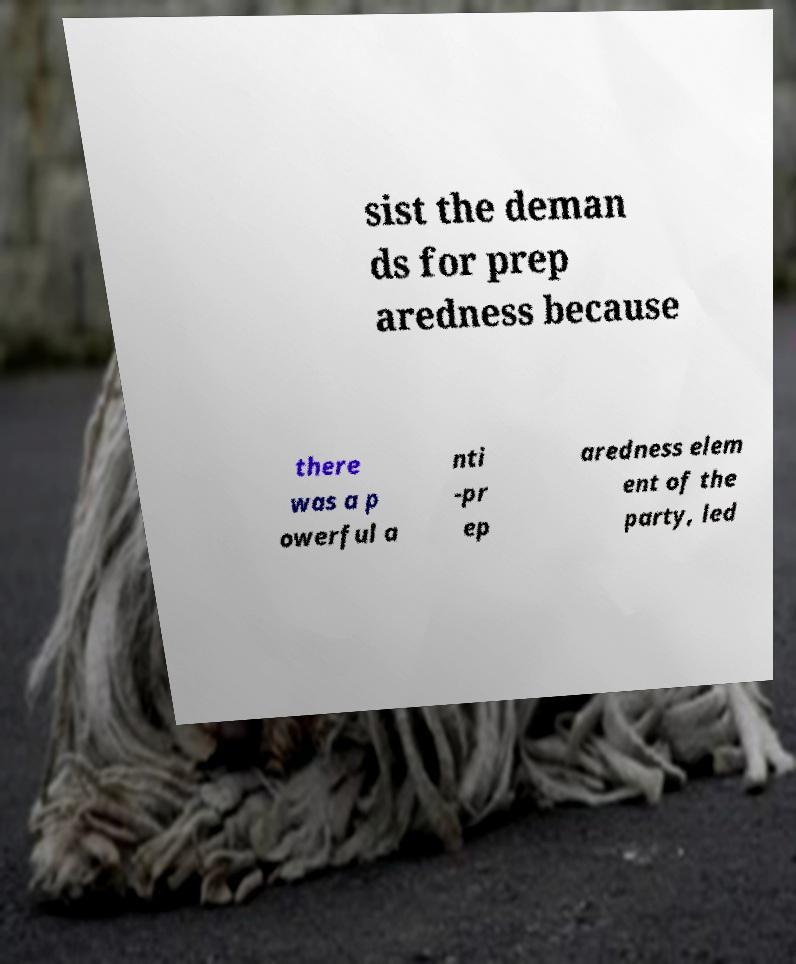Can you read and provide the text displayed in the image?This photo seems to have some interesting text. Can you extract and type it out for me? sist the deman ds for prep aredness because there was a p owerful a nti -pr ep aredness elem ent of the party, led 